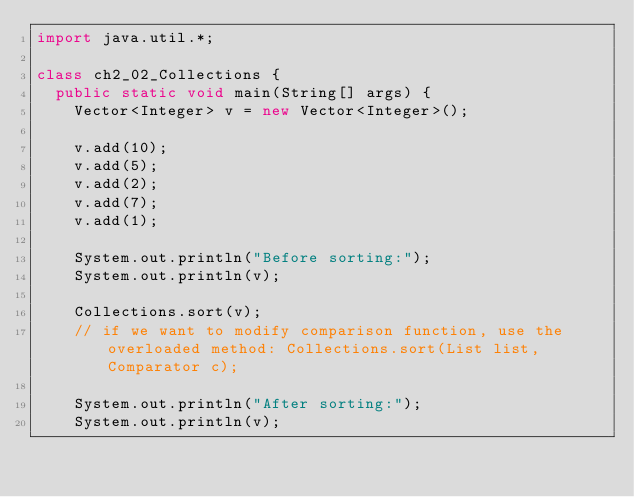<code> <loc_0><loc_0><loc_500><loc_500><_Java_>import java.util.*;

class ch2_02_Collections {
  public static void main(String[] args) {
    Vector<Integer> v = new Vector<Integer>();

    v.add(10);
    v.add(5);
    v.add(2);
    v.add(7);
    v.add(1);

    System.out.println("Before sorting:");
    System.out.println(v);

    Collections.sort(v);
    // if we want to modify comparison function, use the overloaded method: Collections.sort(List list, Comparator c);

    System.out.println("After sorting:");
    System.out.println(v);
</code> 